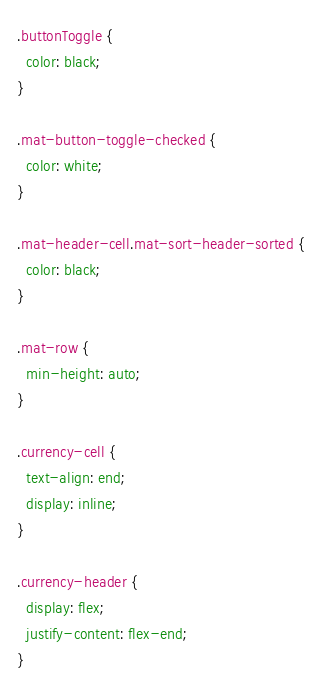<code> <loc_0><loc_0><loc_500><loc_500><_CSS_>.buttonToggle {
  color: black;
}

.mat-button-toggle-checked {
  color: white;
}

.mat-header-cell.mat-sort-header-sorted {
  color: black;
}

.mat-row {
  min-height: auto;
}

.currency-cell {
  text-align: end;
  display: inline;
}

.currency-header {
  display: flex;
  justify-content: flex-end;
}
</code> 